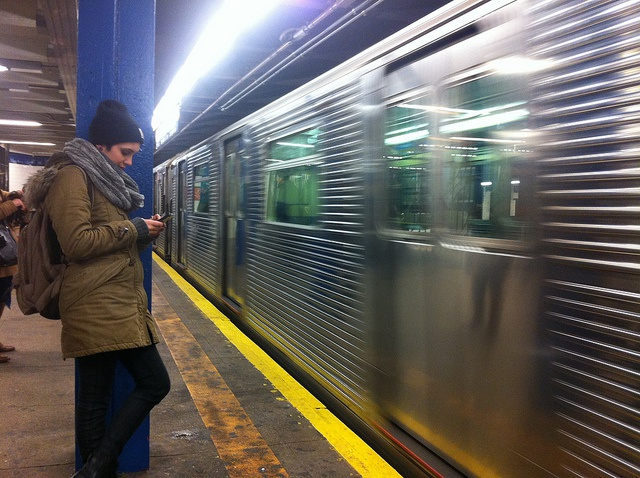Describe the objects in this image and their specific colors. I can see train in black, gray, lightgray, and darkgray tones, people in black, maroon, and gray tones, backpack in black and gray tones, people in black, maroon, gray, and brown tones, and cell phone in black and gray tones in this image. 